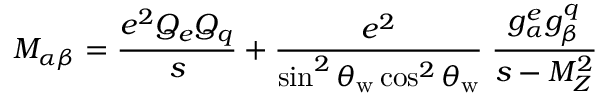Convert formula to latex. <formula><loc_0><loc_0><loc_500><loc_500>M _ { \alpha \beta } = \frac { e ^ { 2 } Q _ { e } Q _ { q } } { s } + \frac { e ^ { 2 } } { \sin ^ { 2 } \theta _ { w } \cos ^ { 2 } \theta _ { w } } \, \frac { g _ { \alpha } ^ { e } g _ { \beta } ^ { q } } { s - M _ { Z } ^ { 2 } }</formula> 